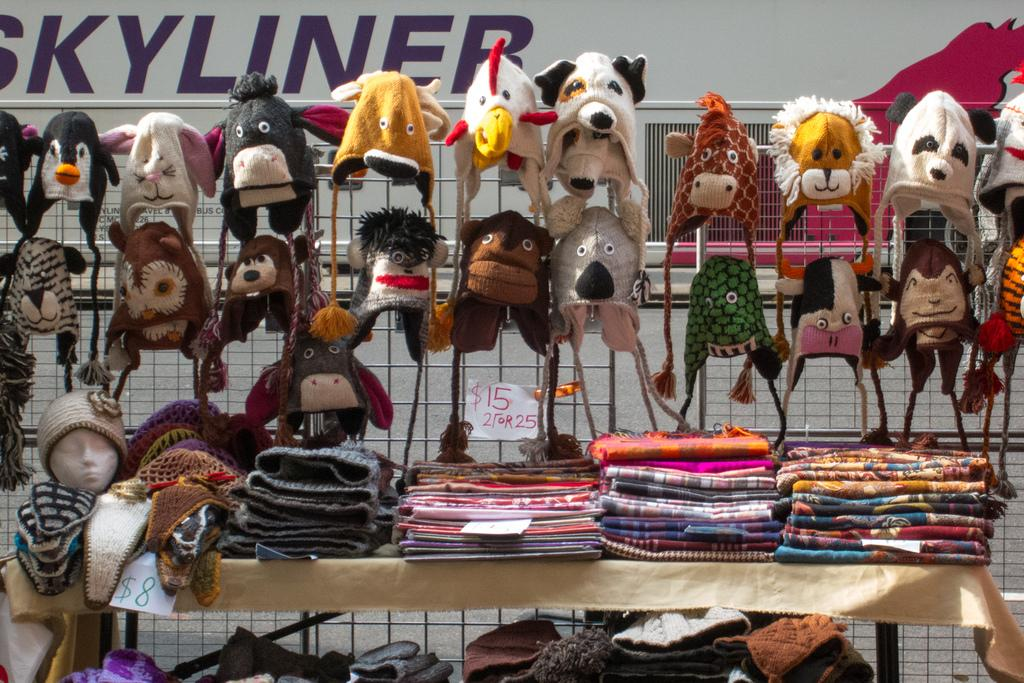What type of items can be seen in the image related to warmth and comfort? There are blankets in the image. What other items related to clothing can be seen in the image? There are clothes and caps in the image. Are there any other objects present in the image besides blankets, clothes, and caps? Yes, there are other objects in the image. What can be seen in the background of the image? There is a vehicle in the background of the image. Can you see a rat hiding under the blankets in the image? No, there is no rat present in the image. 